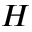<formula> <loc_0><loc_0><loc_500><loc_500>H</formula> 